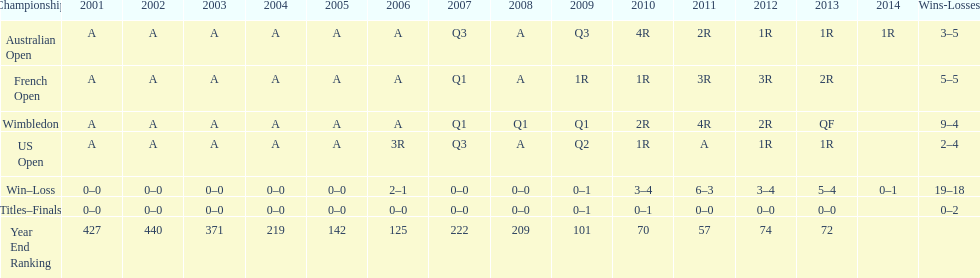Which years was a ranking below 200 achieved? 2005, 2006, 2009, 2010, 2011, 2012, 2013. 